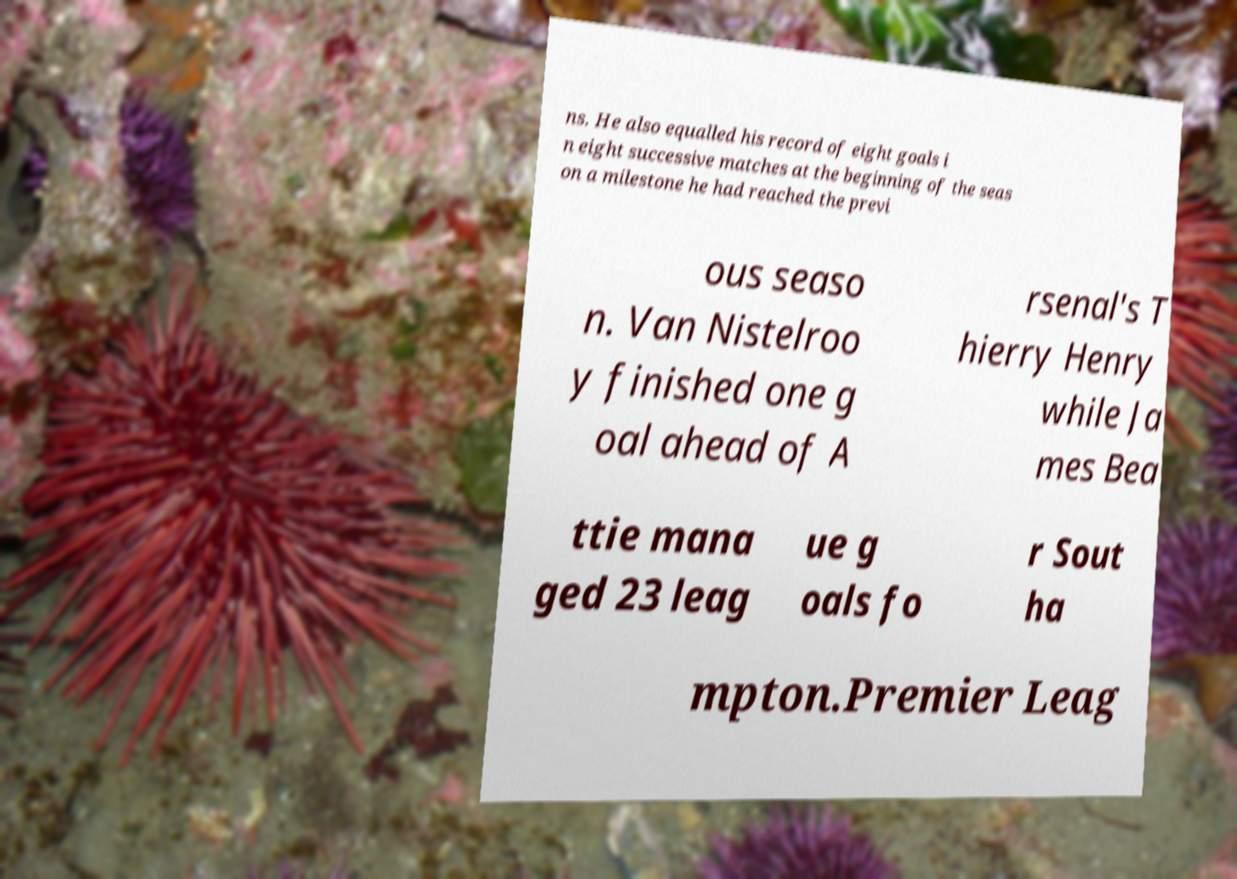Could you assist in decoding the text presented in this image and type it out clearly? ns. He also equalled his record of eight goals i n eight successive matches at the beginning of the seas on a milestone he had reached the previ ous seaso n. Van Nistelroo y finished one g oal ahead of A rsenal's T hierry Henry while Ja mes Bea ttie mana ged 23 leag ue g oals fo r Sout ha mpton.Premier Leag 